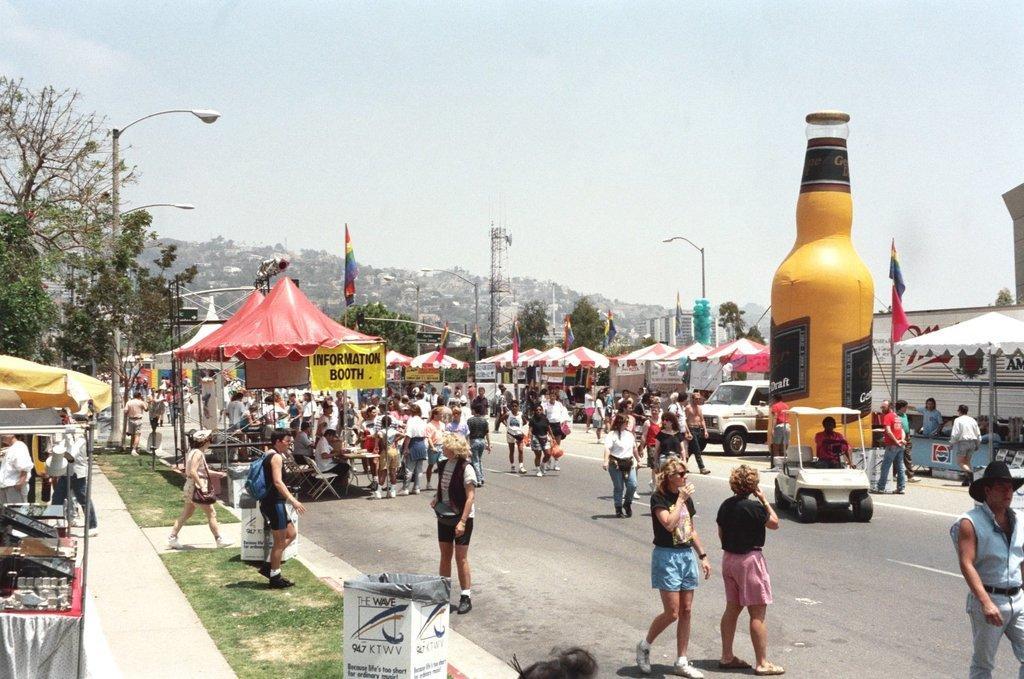Please provide a concise description of this image. In this image we can see so many people are walking on the road. To the both sides of the road canopies are there and trees are present. The sky is in blue color. Right side of the image one yellow color bottle like structure thing is there and even we can see street lights on the both sides of the road. 